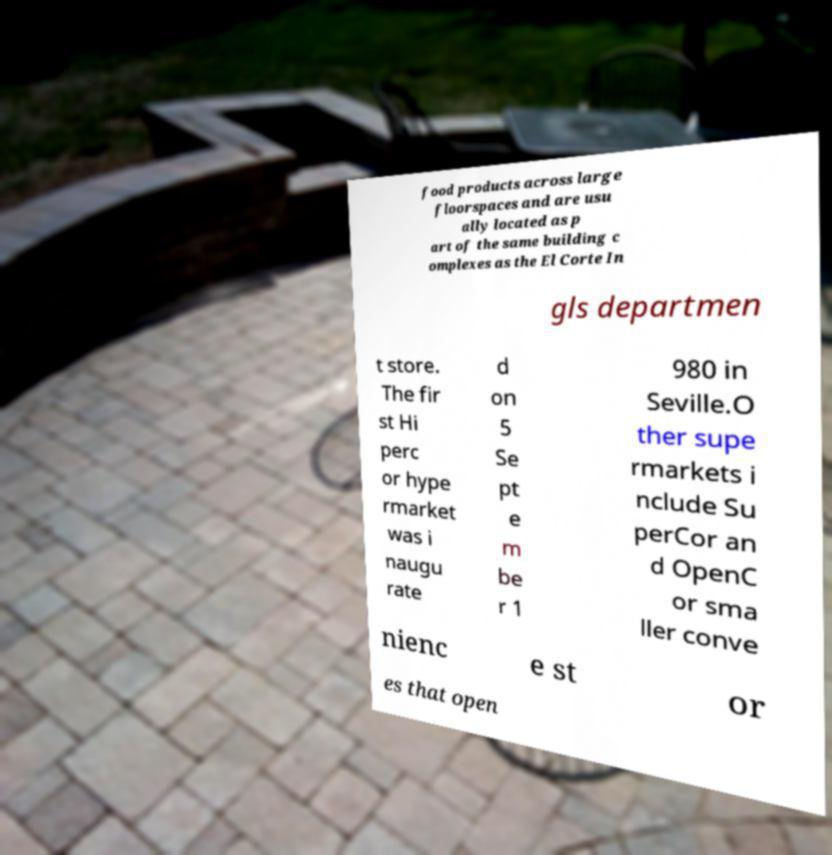Please read and relay the text visible in this image. What does it say? food products across large floorspaces and are usu ally located as p art of the same building c omplexes as the El Corte In gls departmen t store. The fir st Hi perc or hype rmarket was i naugu rate d on 5 Se pt e m be r 1 980 in Seville.O ther supe rmarkets i nclude Su perCor an d OpenC or sma ller conve nienc e st or es that open 